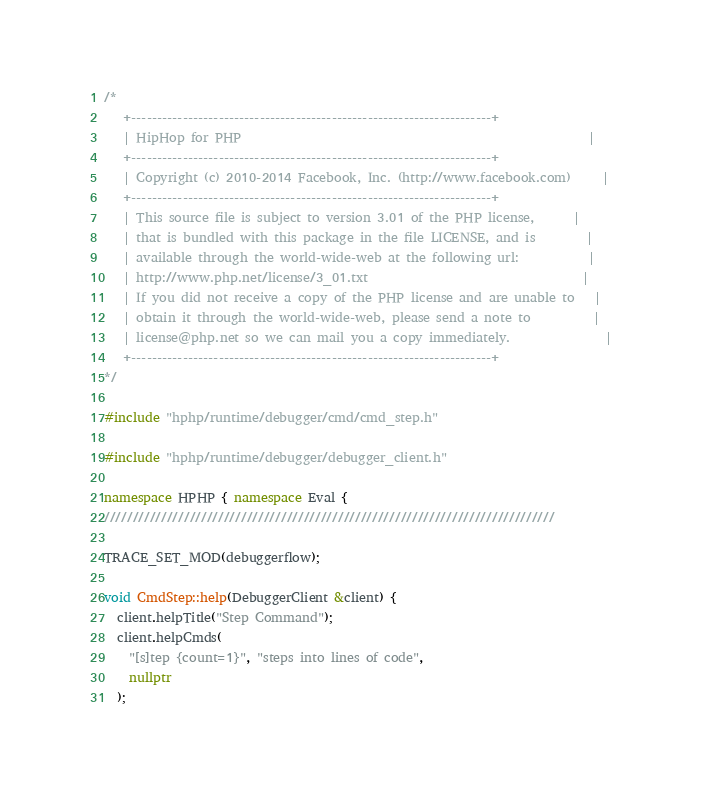Convert code to text. <code><loc_0><loc_0><loc_500><loc_500><_C++_>/*
   +----------------------------------------------------------------------+
   | HipHop for PHP                                                       |
   +----------------------------------------------------------------------+
   | Copyright (c) 2010-2014 Facebook, Inc. (http://www.facebook.com)     |
   +----------------------------------------------------------------------+
   | This source file is subject to version 3.01 of the PHP license,      |
   | that is bundled with this package in the file LICENSE, and is        |
   | available through the world-wide-web at the following url:           |
   | http://www.php.net/license/3_01.txt                                  |
   | If you did not receive a copy of the PHP license and are unable to   |
   | obtain it through the world-wide-web, please send a note to          |
   | license@php.net so we can mail you a copy immediately.               |
   +----------------------------------------------------------------------+
*/

#include "hphp/runtime/debugger/cmd/cmd_step.h"

#include "hphp/runtime/debugger/debugger_client.h"

namespace HPHP { namespace Eval {
///////////////////////////////////////////////////////////////////////////////

TRACE_SET_MOD(debuggerflow);

void CmdStep::help(DebuggerClient &client) {
  client.helpTitle("Step Command");
  client.helpCmds(
    "[s]tep {count=1}", "steps into lines of code",
    nullptr
  );</code> 